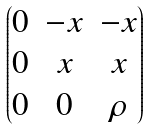Convert formula to latex. <formula><loc_0><loc_0><loc_500><loc_500>\begin{pmatrix} 0 & - x & - x \\ 0 & x & x \\ 0 & 0 & \rho \end{pmatrix}</formula> 